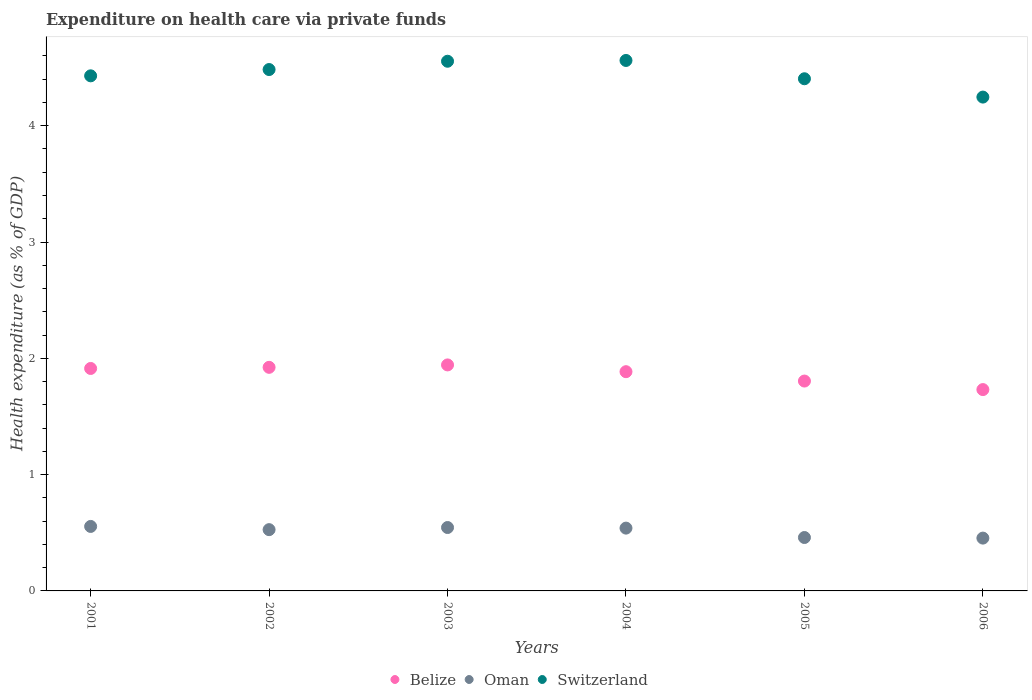What is the expenditure made on health care in Oman in 2001?
Offer a very short reply. 0.55. Across all years, what is the maximum expenditure made on health care in Belize?
Keep it short and to the point. 1.94. Across all years, what is the minimum expenditure made on health care in Belize?
Ensure brevity in your answer.  1.73. In which year was the expenditure made on health care in Oman maximum?
Your response must be concise. 2001. In which year was the expenditure made on health care in Switzerland minimum?
Offer a terse response. 2006. What is the total expenditure made on health care in Oman in the graph?
Provide a succinct answer. 3.08. What is the difference between the expenditure made on health care in Belize in 2003 and that in 2004?
Offer a terse response. 0.06. What is the difference between the expenditure made on health care in Switzerland in 2006 and the expenditure made on health care in Belize in 2004?
Ensure brevity in your answer.  2.36. What is the average expenditure made on health care in Belize per year?
Offer a very short reply. 1.87. In the year 2001, what is the difference between the expenditure made on health care in Oman and expenditure made on health care in Belize?
Provide a succinct answer. -1.36. In how many years, is the expenditure made on health care in Oman greater than 2.2 %?
Offer a terse response. 0. What is the ratio of the expenditure made on health care in Switzerland in 2002 to that in 2004?
Ensure brevity in your answer.  0.98. Is the expenditure made on health care in Switzerland in 2001 less than that in 2004?
Your answer should be very brief. Yes. What is the difference between the highest and the second highest expenditure made on health care in Oman?
Offer a very short reply. 0.01. What is the difference between the highest and the lowest expenditure made on health care in Oman?
Your answer should be very brief. 0.1. Is it the case that in every year, the sum of the expenditure made on health care in Oman and expenditure made on health care in Switzerland  is greater than the expenditure made on health care in Belize?
Ensure brevity in your answer.  Yes. Is the expenditure made on health care in Oman strictly greater than the expenditure made on health care in Belize over the years?
Offer a very short reply. No. How many dotlines are there?
Offer a terse response. 3. Does the graph contain any zero values?
Ensure brevity in your answer.  No. How many legend labels are there?
Ensure brevity in your answer.  3. What is the title of the graph?
Offer a terse response. Expenditure on health care via private funds. What is the label or title of the Y-axis?
Your answer should be very brief. Health expenditure (as % of GDP). What is the Health expenditure (as % of GDP) in Belize in 2001?
Your answer should be compact. 1.91. What is the Health expenditure (as % of GDP) of Oman in 2001?
Your response must be concise. 0.55. What is the Health expenditure (as % of GDP) of Switzerland in 2001?
Make the answer very short. 4.43. What is the Health expenditure (as % of GDP) in Belize in 2002?
Make the answer very short. 1.92. What is the Health expenditure (as % of GDP) in Oman in 2002?
Your answer should be very brief. 0.53. What is the Health expenditure (as % of GDP) in Switzerland in 2002?
Offer a very short reply. 4.48. What is the Health expenditure (as % of GDP) in Belize in 2003?
Make the answer very short. 1.94. What is the Health expenditure (as % of GDP) in Oman in 2003?
Your answer should be very brief. 0.55. What is the Health expenditure (as % of GDP) of Switzerland in 2003?
Your answer should be very brief. 4.55. What is the Health expenditure (as % of GDP) of Belize in 2004?
Provide a succinct answer. 1.88. What is the Health expenditure (as % of GDP) in Oman in 2004?
Offer a terse response. 0.54. What is the Health expenditure (as % of GDP) in Switzerland in 2004?
Give a very brief answer. 4.56. What is the Health expenditure (as % of GDP) in Belize in 2005?
Offer a very short reply. 1.8. What is the Health expenditure (as % of GDP) of Oman in 2005?
Your answer should be compact. 0.46. What is the Health expenditure (as % of GDP) of Switzerland in 2005?
Give a very brief answer. 4.4. What is the Health expenditure (as % of GDP) in Belize in 2006?
Make the answer very short. 1.73. What is the Health expenditure (as % of GDP) of Oman in 2006?
Offer a very short reply. 0.45. What is the Health expenditure (as % of GDP) in Switzerland in 2006?
Offer a terse response. 4.25. Across all years, what is the maximum Health expenditure (as % of GDP) of Belize?
Your answer should be very brief. 1.94. Across all years, what is the maximum Health expenditure (as % of GDP) of Oman?
Keep it short and to the point. 0.55. Across all years, what is the maximum Health expenditure (as % of GDP) in Switzerland?
Provide a succinct answer. 4.56. Across all years, what is the minimum Health expenditure (as % of GDP) in Belize?
Give a very brief answer. 1.73. Across all years, what is the minimum Health expenditure (as % of GDP) in Oman?
Your answer should be compact. 0.45. Across all years, what is the minimum Health expenditure (as % of GDP) of Switzerland?
Provide a short and direct response. 4.25. What is the total Health expenditure (as % of GDP) in Belize in the graph?
Provide a short and direct response. 11.2. What is the total Health expenditure (as % of GDP) of Oman in the graph?
Your response must be concise. 3.08. What is the total Health expenditure (as % of GDP) of Switzerland in the graph?
Offer a very short reply. 26.68. What is the difference between the Health expenditure (as % of GDP) of Belize in 2001 and that in 2002?
Offer a terse response. -0.01. What is the difference between the Health expenditure (as % of GDP) of Oman in 2001 and that in 2002?
Ensure brevity in your answer.  0.03. What is the difference between the Health expenditure (as % of GDP) of Switzerland in 2001 and that in 2002?
Ensure brevity in your answer.  -0.05. What is the difference between the Health expenditure (as % of GDP) of Belize in 2001 and that in 2003?
Your answer should be compact. -0.03. What is the difference between the Health expenditure (as % of GDP) in Oman in 2001 and that in 2003?
Provide a succinct answer. 0.01. What is the difference between the Health expenditure (as % of GDP) in Switzerland in 2001 and that in 2003?
Your answer should be compact. -0.13. What is the difference between the Health expenditure (as % of GDP) in Belize in 2001 and that in 2004?
Offer a very short reply. 0.03. What is the difference between the Health expenditure (as % of GDP) of Oman in 2001 and that in 2004?
Keep it short and to the point. 0.01. What is the difference between the Health expenditure (as % of GDP) in Switzerland in 2001 and that in 2004?
Make the answer very short. -0.13. What is the difference between the Health expenditure (as % of GDP) of Belize in 2001 and that in 2005?
Your response must be concise. 0.11. What is the difference between the Health expenditure (as % of GDP) in Oman in 2001 and that in 2005?
Offer a very short reply. 0.1. What is the difference between the Health expenditure (as % of GDP) in Switzerland in 2001 and that in 2005?
Provide a succinct answer. 0.03. What is the difference between the Health expenditure (as % of GDP) of Belize in 2001 and that in 2006?
Your answer should be very brief. 0.18. What is the difference between the Health expenditure (as % of GDP) of Oman in 2001 and that in 2006?
Provide a succinct answer. 0.1. What is the difference between the Health expenditure (as % of GDP) in Switzerland in 2001 and that in 2006?
Offer a terse response. 0.18. What is the difference between the Health expenditure (as % of GDP) in Belize in 2002 and that in 2003?
Offer a terse response. -0.02. What is the difference between the Health expenditure (as % of GDP) of Oman in 2002 and that in 2003?
Provide a succinct answer. -0.02. What is the difference between the Health expenditure (as % of GDP) of Switzerland in 2002 and that in 2003?
Make the answer very short. -0.07. What is the difference between the Health expenditure (as % of GDP) of Belize in 2002 and that in 2004?
Make the answer very short. 0.04. What is the difference between the Health expenditure (as % of GDP) of Oman in 2002 and that in 2004?
Keep it short and to the point. -0.01. What is the difference between the Health expenditure (as % of GDP) of Switzerland in 2002 and that in 2004?
Provide a short and direct response. -0.08. What is the difference between the Health expenditure (as % of GDP) in Belize in 2002 and that in 2005?
Your answer should be very brief. 0.12. What is the difference between the Health expenditure (as % of GDP) in Oman in 2002 and that in 2005?
Provide a succinct answer. 0.07. What is the difference between the Health expenditure (as % of GDP) in Switzerland in 2002 and that in 2005?
Provide a short and direct response. 0.08. What is the difference between the Health expenditure (as % of GDP) of Belize in 2002 and that in 2006?
Your answer should be compact. 0.19. What is the difference between the Health expenditure (as % of GDP) of Oman in 2002 and that in 2006?
Give a very brief answer. 0.07. What is the difference between the Health expenditure (as % of GDP) in Switzerland in 2002 and that in 2006?
Keep it short and to the point. 0.24. What is the difference between the Health expenditure (as % of GDP) in Belize in 2003 and that in 2004?
Offer a terse response. 0.06. What is the difference between the Health expenditure (as % of GDP) in Oman in 2003 and that in 2004?
Offer a very short reply. 0.01. What is the difference between the Health expenditure (as % of GDP) of Switzerland in 2003 and that in 2004?
Make the answer very short. -0.01. What is the difference between the Health expenditure (as % of GDP) in Belize in 2003 and that in 2005?
Your answer should be compact. 0.14. What is the difference between the Health expenditure (as % of GDP) in Oman in 2003 and that in 2005?
Make the answer very short. 0.09. What is the difference between the Health expenditure (as % of GDP) of Switzerland in 2003 and that in 2005?
Keep it short and to the point. 0.15. What is the difference between the Health expenditure (as % of GDP) in Belize in 2003 and that in 2006?
Ensure brevity in your answer.  0.21. What is the difference between the Health expenditure (as % of GDP) of Oman in 2003 and that in 2006?
Your answer should be very brief. 0.09. What is the difference between the Health expenditure (as % of GDP) of Switzerland in 2003 and that in 2006?
Make the answer very short. 0.31. What is the difference between the Health expenditure (as % of GDP) of Belize in 2004 and that in 2005?
Provide a short and direct response. 0.08. What is the difference between the Health expenditure (as % of GDP) in Oman in 2004 and that in 2005?
Provide a succinct answer. 0.08. What is the difference between the Health expenditure (as % of GDP) of Switzerland in 2004 and that in 2005?
Your answer should be very brief. 0.16. What is the difference between the Health expenditure (as % of GDP) of Belize in 2004 and that in 2006?
Keep it short and to the point. 0.15. What is the difference between the Health expenditure (as % of GDP) of Oman in 2004 and that in 2006?
Ensure brevity in your answer.  0.09. What is the difference between the Health expenditure (as % of GDP) of Switzerland in 2004 and that in 2006?
Provide a short and direct response. 0.31. What is the difference between the Health expenditure (as % of GDP) in Belize in 2005 and that in 2006?
Keep it short and to the point. 0.07. What is the difference between the Health expenditure (as % of GDP) of Oman in 2005 and that in 2006?
Make the answer very short. 0.01. What is the difference between the Health expenditure (as % of GDP) of Switzerland in 2005 and that in 2006?
Offer a very short reply. 0.16. What is the difference between the Health expenditure (as % of GDP) of Belize in 2001 and the Health expenditure (as % of GDP) of Oman in 2002?
Ensure brevity in your answer.  1.39. What is the difference between the Health expenditure (as % of GDP) of Belize in 2001 and the Health expenditure (as % of GDP) of Switzerland in 2002?
Make the answer very short. -2.57. What is the difference between the Health expenditure (as % of GDP) of Oman in 2001 and the Health expenditure (as % of GDP) of Switzerland in 2002?
Provide a succinct answer. -3.93. What is the difference between the Health expenditure (as % of GDP) in Belize in 2001 and the Health expenditure (as % of GDP) in Oman in 2003?
Your answer should be compact. 1.37. What is the difference between the Health expenditure (as % of GDP) of Belize in 2001 and the Health expenditure (as % of GDP) of Switzerland in 2003?
Provide a short and direct response. -2.64. What is the difference between the Health expenditure (as % of GDP) in Oman in 2001 and the Health expenditure (as % of GDP) in Switzerland in 2003?
Your response must be concise. -4. What is the difference between the Health expenditure (as % of GDP) in Belize in 2001 and the Health expenditure (as % of GDP) in Oman in 2004?
Make the answer very short. 1.37. What is the difference between the Health expenditure (as % of GDP) in Belize in 2001 and the Health expenditure (as % of GDP) in Switzerland in 2004?
Keep it short and to the point. -2.65. What is the difference between the Health expenditure (as % of GDP) of Oman in 2001 and the Health expenditure (as % of GDP) of Switzerland in 2004?
Provide a succinct answer. -4.01. What is the difference between the Health expenditure (as % of GDP) in Belize in 2001 and the Health expenditure (as % of GDP) in Oman in 2005?
Your response must be concise. 1.45. What is the difference between the Health expenditure (as % of GDP) in Belize in 2001 and the Health expenditure (as % of GDP) in Switzerland in 2005?
Your answer should be compact. -2.49. What is the difference between the Health expenditure (as % of GDP) of Oman in 2001 and the Health expenditure (as % of GDP) of Switzerland in 2005?
Offer a very short reply. -3.85. What is the difference between the Health expenditure (as % of GDP) in Belize in 2001 and the Health expenditure (as % of GDP) in Oman in 2006?
Give a very brief answer. 1.46. What is the difference between the Health expenditure (as % of GDP) in Belize in 2001 and the Health expenditure (as % of GDP) in Switzerland in 2006?
Your answer should be very brief. -2.33. What is the difference between the Health expenditure (as % of GDP) in Oman in 2001 and the Health expenditure (as % of GDP) in Switzerland in 2006?
Ensure brevity in your answer.  -3.69. What is the difference between the Health expenditure (as % of GDP) of Belize in 2002 and the Health expenditure (as % of GDP) of Oman in 2003?
Your response must be concise. 1.38. What is the difference between the Health expenditure (as % of GDP) in Belize in 2002 and the Health expenditure (as % of GDP) in Switzerland in 2003?
Keep it short and to the point. -2.63. What is the difference between the Health expenditure (as % of GDP) of Oman in 2002 and the Health expenditure (as % of GDP) of Switzerland in 2003?
Keep it short and to the point. -4.03. What is the difference between the Health expenditure (as % of GDP) in Belize in 2002 and the Health expenditure (as % of GDP) in Oman in 2004?
Give a very brief answer. 1.38. What is the difference between the Health expenditure (as % of GDP) in Belize in 2002 and the Health expenditure (as % of GDP) in Switzerland in 2004?
Offer a terse response. -2.64. What is the difference between the Health expenditure (as % of GDP) of Oman in 2002 and the Health expenditure (as % of GDP) of Switzerland in 2004?
Your answer should be very brief. -4.03. What is the difference between the Health expenditure (as % of GDP) of Belize in 2002 and the Health expenditure (as % of GDP) of Oman in 2005?
Keep it short and to the point. 1.46. What is the difference between the Health expenditure (as % of GDP) in Belize in 2002 and the Health expenditure (as % of GDP) in Switzerland in 2005?
Provide a succinct answer. -2.48. What is the difference between the Health expenditure (as % of GDP) in Oman in 2002 and the Health expenditure (as % of GDP) in Switzerland in 2005?
Keep it short and to the point. -3.88. What is the difference between the Health expenditure (as % of GDP) of Belize in 2002 and the Health expenditure (as % of GDP) of Oman in 2006?
Provide a short and direct response. 1.47. What is the difference between the Health expenditure (as % of GDP) in Belize in 2002 and the Health expenditure (as % of GDP) in Switzerland in 2006?
Provide a succinct answer. -2.32. What is the difference between the Health expenditure (as % of GDP) of Oman in 2002 and the Health expenditure (as % of GDP) of Switzerland in 2006?
Your answer should be compact. -3.72. What is the difference between the Health expenditure (as % of GDP) in Belize in 2003 and the Health expenditure (as % of GDP) in Oman in 2004?
Give a very brief answer. 1.4. What is the difference between the Health expenditure (as % of GDP) of Belize in 2003 and the Health expenditure (as % of GDP) of Switzerland in 2004?
Ensure brevity in your answer.  -2.62. What is the difference between the Health expenditure (as % of GDP) in Oman in 2003 and the Health expenditure (as % of GDP) in Switzerland in 2004?
Give a very brief answer. -4.02. What is the difference between the Health expenditure (as % of GDP) in Belize in 2003 and the Health expenditure (as % of GDP) in Oman in 2005?
Give a very brief answer. 1.48. What is the difference between the Health expenditure (as % of GDP) of Belize in 2003 and the Health expenditure (as % of GDP) of Switzerland in 2005?
Make the answer very short. -2.46. What is the difference between the Health expenditure (as % of GDP) of Oman in 2003 and the Health expenditure (as % of GDP) of Switzerland in 2005?
Ensure brevity in your answer.  -3.86. What is the difference between the Health expenditure (as % of GDP) in Belize in 2003 and the Health expenditure (as % of GDP) in Oman in 2006?
Offer a terse response. 1.49. What is the difference between the Health expenditure (as % of GDP) in Belize in 2003 and the Health expenditure (as % of GDP) in Switzerland in 2006?
Your answer should be compact. -2.3. What is the difference between the Health expenditure (as % of GDP) of Oman in 2003 and the Health expenditure (as % of GDP) of Switzerland in 2006?
Provide a succinct answer. -3.7. What is the difference between the Health expenditure (as % of GDP) of Belize in 2004 and the Health expenditure (as % of GDP) of Oman in 2005?
Keep it short and to the point. 1.43. What is the difference between the Health expenditure (as % of GDP) of Belize in 2004 and the Health expenditure (as % of GDP) of Switzerland in 2005?
Your response must be concise. -2.52. What is the difference between the Health expenditure (as % of GDP) of Oman in 2004 and the Health expenditure (as % of GDP) of Switzerland in 2005?
Provide a short and direct response. -3.86. What is the difference between the Health expenditure (as % of GDP) of Belize in 2004 and the Health expenditure (as % of GDP) of Oman in 2006?
Offer a terse response. 1.43. What is the difference between the Health expenditure (as % of GDP) of Belize in 2004 and the Health expenditure (as % of GDP) of Switzerland in 2006?
Your answer should be compact. -2.36. What is the difference between the Health expenditure (as % of GDP) in Oman in 2004 and the Health expenditure (as % of GDP) in Switzerland in 2006?
Offer a terse response. -3.71. What is the difference between the Health expenditure (as % of GDP) in Belize in 2005 and the Health expenditure (as % of GDP) in Oman in 2006?
Your response must be concise. 1.35. What is the difference between the Health expenditure (as % of GDP) in Belize in 2005 and the Health expenditure (as % of GDP) in Switzerland in 2006?
Give a very brief answer. -2.44. What is the difference between the Health expenditure (as % of GDP) of Oman in 2005 and the Health expenditure (as % of GDP) of Switzerland in 2006?
Your answer should be compact. -3.79. What is the average Health expenditure (as % of GDP) in Belize per year?
Keep it short and to the point. 1.87. What is the average Health expenditure (as % of GDP) of Oman per year?
Make the answer very short. 0.51. What is the average Health expenditure (as % of GDP) of Switzerland per year?
Your response must be concise. 4.45. In the year 2001, what is the difference between the Health expenditure (as % of GDP) of Belize and Health expenditure (as % of GDP) of Oman?
Your answer should be compact. 1.36. In the year 2001, what is the difference between the Health expenditure (as % of GDP) of Belize and Health expenditure (as % of GDP) of Switzerland?
Your answer should be very brief. -2.52. In the year 2001, what is the difference between the Health expenditure (as % of GDP) of Oman and Health expenditure (as % of GDP) of Switzerland?
Provide a short and direct response. -3.87. In the year 2002, what is the difference between the Health expenditure (as % of GDP) of Belize and Health expenditure (as % of GDP) of Oman?
Ensure brevity in your answer.  1.4. In the year 2002, what is the difference between the Health expenditure (as % of GDP) in Belize and Health expenditure (as % of GDP) in Switzerland?
Provide a succinct answer. -2.56. In the year 2002, what is the difference between the Health expenditure (as % of GDP) of Oman and Health expenditure (as % of GDP) of Switzerland?
Keep it short and to the point. -3.96. In the year 2003, what is the difference between the Health expenditure (as % of GDP) in Belize and Health expenditure (as % of GDP) in Oman?
Provide a short and direct response. 1.4. In the year 2003, what is the difference between the Health expenditure (as % of GDP) in Belize and Health expenditure (as % of GDP) in Switzerland?
Offer a terse response. -2.61. In the year 2003, what is the difference between the Health expenditure (as % of GDP) in Oman and Health expenditure (as % of GDP) in Switzerland?
Your response must be concise. -4.01. In the year 2004, what is the difference between the Health expenditure (as % of GDP) of Belize and Health expenditure (as % of GDP) of Oman?
Your response must be concise. 1.34. In the year 2004, what is the difference between the Health expenditure (as % of GDP) in Belize and Health expenditure (as % of GDP) in Switzerland?
Your answer should be very brief. -2.68. In the year 2004, what is the difference between the Health expenditure (as % of GDP) in Oman and Health expenditure (as % of GDP) in Switzerland?
Offer a very short reply. -4.02. In the year 2005, what is the difference between the Health expenditure (as % of GDP) in Belize and Health expenditure (as % of GDP) in Oman?
Keep it short and to the point. 1.35. In the year 2005, what is the difference between the Health expenditure (as % of GDP) of Belize and Health expenditure (as % of GDP) of Switzerland?
Your answer should be very brief. -2.6. In the year 2005, what is the difference between the Health expenditure (as % of GDP) of Oman and Health expenditure (as % of GDP) of Switzerland?
Provide a short and direct response. -3.94. In the year 2006, what is the difference between the Health expenditure (as % of GDP) of Belize and Health expenditure (as % of GDP) of Oman?
Your answer should be very brief. 1.28. In the year 2006, what is the difference between the Health expenditure (as % of GDP) in Belize and Health expenditure (as % of GDP) in Switzerland?
Your response must be concise. -2.51. In the year 2006, what is the difference between the Health expenditure (as % of GDP) in Oman and Health expenditure (as % of GDP) in Switzerland?
Your answer should be compact. -3.79. What is the ratio of the Health expenditure (as % of GDP) in Belize in 2001 to that in 2002?
Your answer should be very brief. 0.99. What is the ratio of the Health expenditure (as % of GDP) of Oman in 2001 to that in 2002?
Offer a very short reply. 1.05. What is the ratio of the Health expenditure (as % of GDP) in Switzerland in 2001 to that in 2002?
Offer a very short reply. 0.99. What is the ratio of the Health expenditure (as % of GDP) in Belize in 2001 to that in 2003?
Keep it short and to the point. 0.98. What is the ratio of the Health expenditure (as % of GDP) of Oman in 2001 to that in 2003?
Keep it short and to the point. 1.02. What is the ratio of the Health expenditure (as % of GDP) of Switzerland in 2001 to that in 2003?
Give a very brief answer. 0.97. What is the ratio of the Health expenditure (as % of GDP) in Belize in 2001 to that in 2004?
Keep it short and to the point. 1.01. What is the ratio of the Health expenditure (as % of GDP) of Oman in 2001 to that in 2004?
Your response must be concise. 1.03. What is the ratio of the Health expenditure (as % of GDP) of Switzerland in 2001 to that in 2004?
Your response must be concise. 0.97. What is the ratio of the Health expenditure (as % of GDP) in Belize in 2001 to that in 2005?
Ensure brevity in your answer.  1.06. What is the ratio of the Health expenditure (as % of GDP) in Oman in 2001 to that in 2005?
Provide a succinct answer. 1.21. What is the ratio of the Health expenditure (as % of GDP) of Switzerland in 2001 to that in 2005?
Offer a very short reply. 1.01. What is the ratio of the Health expenditure (as % of GDP) in Belize in 2001 to that in 2006?
Provide a short and direct response. 1.1. What is the ratio of the Health expenditure (as % of GDP) of Oman in 2001 to that in 2006?
Keep it short and to the point. 1.22. What is the ratio of the Health expenditure (as % of GDP) of Switzerland in 2001 to that in 2006?
Your answer should be compact. 1.04. What is the ratio of the Health expenditure (as % of GDP) in Belize in 2002 to that in 2003?
Make the answer very short. 0.99. What is the ratio of the Health expenditure (as % of GDP) of Oman in 2002 to that in 2003?
Make the answer very short. 0.97. What is the ratio of the Health expenditure (as % of GDP) in Switzerland in 2002 to that in 2003?
Keep it short and to the point. 0.98. What is the ratio of the Health expenditure (as % of GDP) of Belize in 2002 to that in 2004?
Ensure brevity in your answer.  1.02. What is the ratio of the Health expenditure (as % of GDP) in Oman in 2002 to that in 2004?
Your answer should be very brief. 0.98. What is the ratio of the Health expenditure (as % of GDP) of Switzerland in 2002 to that in 2004?
Provide a short and direct response. 0.98. What is the ratio of the Health expenditure (as % of GDP) of Belize in 2002 to that in 2005?
Provide a short and direct response. 1.07. What is the ratio of the Health expenditure (as % of GDP) of Oman in 2002 to that in 2005?
Keep it short and to the point. 1.15. What is the ratio of the Health expenditure (as % of GDP) of Belize in 2002 to that in 2006?
Give a very brief answer. 1.11. What is the ratio of the Health expenditure (as % of GDP) of Oman in 2002 to that in 2006?
Offer a very short reply. 1.16. What is the ratio of the Health expenditure (as % of GDP) in Switzerland in 2002 to that in 2006?
Make the answer very short. 1.06. What is the ratio of the Health expenditure (as % of GDP) of Belize in 2003 to that in 2004?
Provide a succinct answer. 1.03. What is the ratio of the Health expenditure (as % of GDP) in Oman in 2003 to that in 2004?
Offer a terse response. 1.01. What is the ratio of the Health expenditure (as % of GDP) of Belize in 2003 to that in 2005?
Provide a short and direct response. 1.08. What is the ratio of the Health expenditure (as % of GDP) of Oman in 2003 to that in 2005?
Your response must be concise. 1.19. What is the ratio of the Health expenditure (as % of GDP) of Switzerland in 2003 to that in 2005?
Provide a short and direct response. 1.03. What is the ratio of the Health expenditure (as % of GDP) of Belize in 2003 to that in 2006?
Offer a terse response. 1.12. What is the ratio of the Health expenditure (as % of GDP) in Oman in 2003 to that in 2006?
Offer a very short reply. 1.2. What is the ratio of the Health expenditure (as % of GDP) of Switzerland in 2003 to that in 2006?
Offer a terse response. 1.07. What is the ratio of the Health expenditure (as % of GDP) in Belize in 2004 to that in 2005?
Offer a terse response. 1.04. What is the ratio of the Health expenditure (as % of GDP) of Oman in 2004 to that in 2005?
Your answer should be compact. 1.18. What is the ratio of the Health expenditure (as % of GDP) in Switzerland in 2004 to that in 2005?
Provide a succinct answer. 1.04. What is the ratio of the Health expenditure (as % of GDP) of Belize in 2004 to that in 2006?
Your answer should be very brief. 1.09. What is the ratio of the Health expenditure (as % of GDP) of Oman in 2004 to that in 2006?
Provide a succinct answer. 1.19. What is the ratio of the Health expenditure (as % of GDP) of Switzerland in 2004 to that in 2006?
Make the answer very short. 1.07. What is the ratio of the Health expenditure (as % of GDP) in Belize in 2005 to that in 2006?
Provide a short and direct response. 1.04. What is the ratio of the Health expenditure (as % of GDP) of Oman in 2005 to that in 2006?
Offer a terse response. 1.01. What is the ratio of the Health expenditure (as % of GDP) in Switzerland in 2005 to that in 2006?
Offer a very short reply. 1.04. What is the difference between the highest and the second highest Health expenditure (as % of GDP) in Belize?
Ensure brevity in your answer.  0.02. What is the difference between the highest and the second highest Health expenditure (as % of GDP) of Oman?
Offer a terse response. 0.01. What is the difference between the highest and the second highest Health expenditure (as % of GDP) of Switzerland?
Provide a short and direct response. 0.01. What is the difference between the highest and the lowest Health expenditure (as % of GDP) of Belize?
Ensure brevity in your answer.  0.21. What is the difference between the highest and the lowest Health expenditure (as % of GDP) of Oman?
Provide a succinct answer. 0.1. What is the difference between the highest and the lowest Health expenditure (as % of GDP) of Switzerland?
Your answer should be very brief. 0.31. 